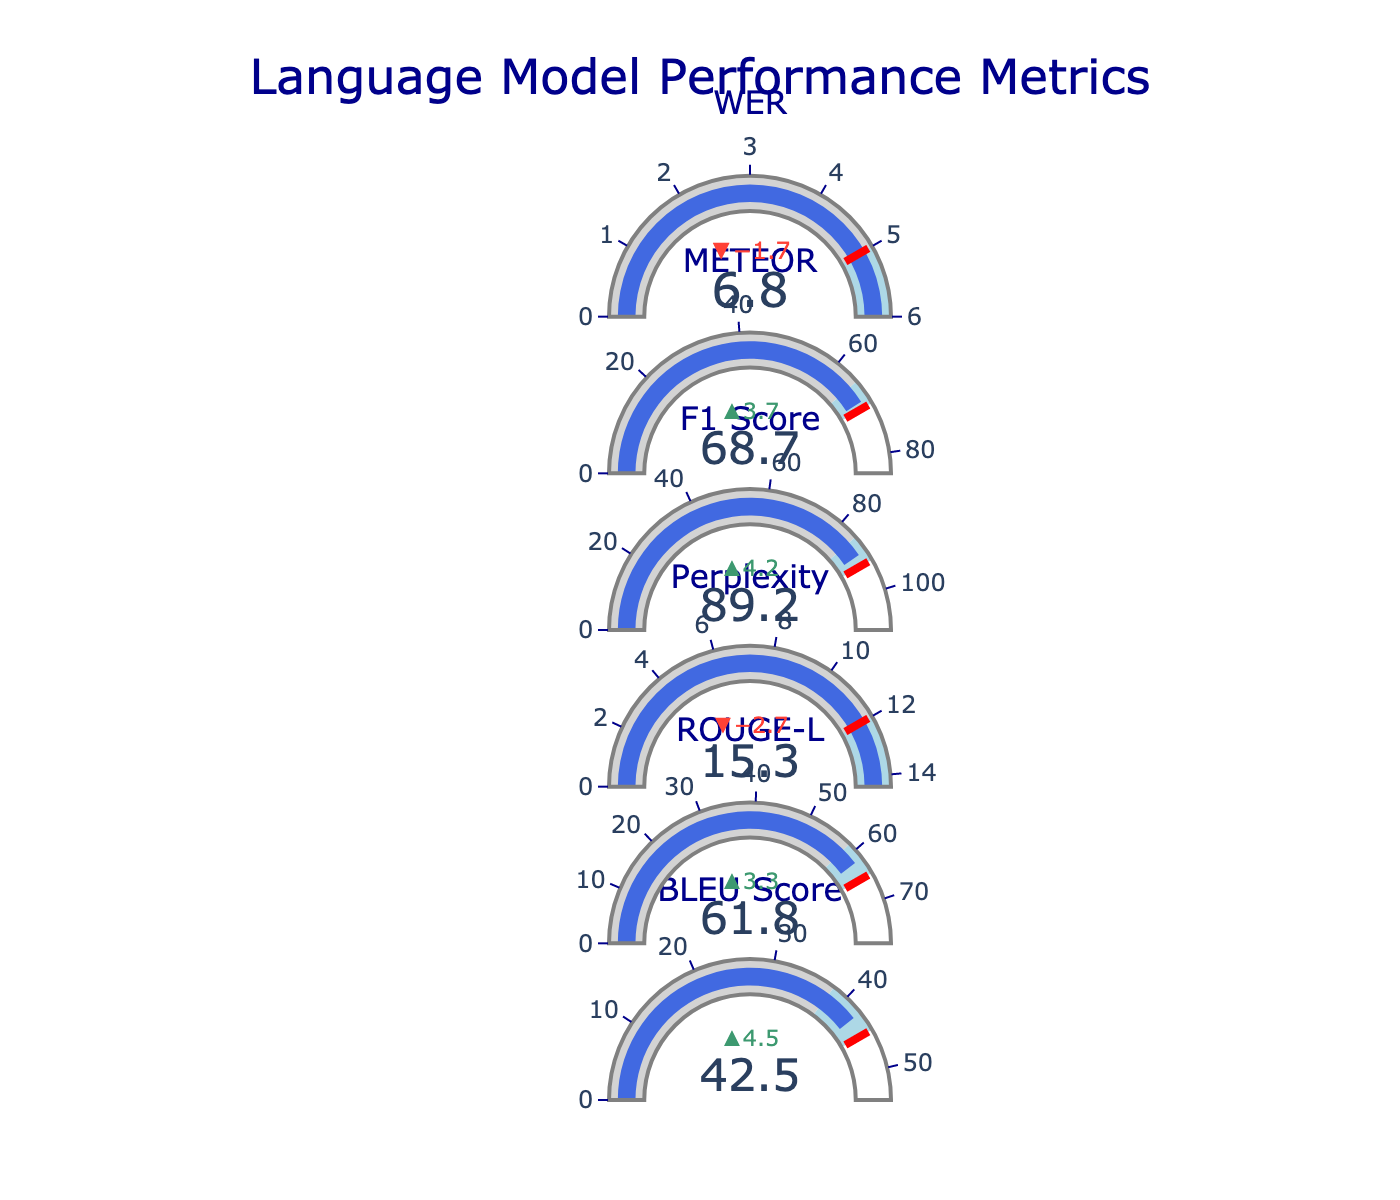What is the title of the figure? The title of the figure is usually positioned at the top and is typically in a larger or bold font. In this case, it is described as "Language Model Performance Metrics."
Answer: Language Model Performance Metrics What is the actual value of the BLEU Score? The actual value of a metric can be read directly from the visual representation of that metric. For BLEU Score, the actual value is shown alongside the gauge and delta indicator.
Answer: 42.5 How many performance metrics are shown in the figure? From the data provided, there are six different metrics: BLEU Score, ROUGE-L, Perplexity, F1 Score, METEOR, and WER.
Answer: 6 What is the target value for the Perplexity metric? Targets are often indicated with a threshold marker in bullet charts. For Perplexity, the given target value is found in the data provided.
Answer: 12.0 Which metric has the highest benchmark value? By comparing the benchmark values for each metric in the data, the highest can be identified. ROUGE-L has the benchmark value of 58.5, which is the highest.
Answer: ROUGE-L What is the difference between the actual and benchmark values for the F1 Score? To find the difference, subtract the benchmark value from the actual value for the F1 Score. 89.2 - 85.0 = 4.2.
Answer: 4.2 Are there any metrics where the actual value is better (i.e., lower for error metrics, higher for performance metrics) than the benchmark value? Compare the actual value with the benchmark for each metric. For BLEU Score, ROUGE-L, F1 Score, and METEOR, the actual values are higher than the benchmarks, and for Perplexity and WER, the actual values are lower than the benchmarks.
Answer: Yes, six metrics What is the average of all target values? Sum up all the target values and divide by the number of metrics. Sum(45.0 + 65.0 + 12.0 + 92.0 + 70.0 + 5.0) = 289.0. Average = 289.0 / 6 ≈ 48.17.
Answer: 48.17 Which metric shows the largest improvement compared to the benchmark? Compare the deltas (actual value minus benchmark value) for each metric to find the largest improvement. METEOR shows the largest improvement as 68.7 - 65.0 = 3.7.
Answer: METEOR What color represents the bar indicating the actual performance in the gauges? The bar color for actual performance is generally distinctive and consistent across metrics. The description specifies the bar color as "royal blue."
Answer: royal blue 